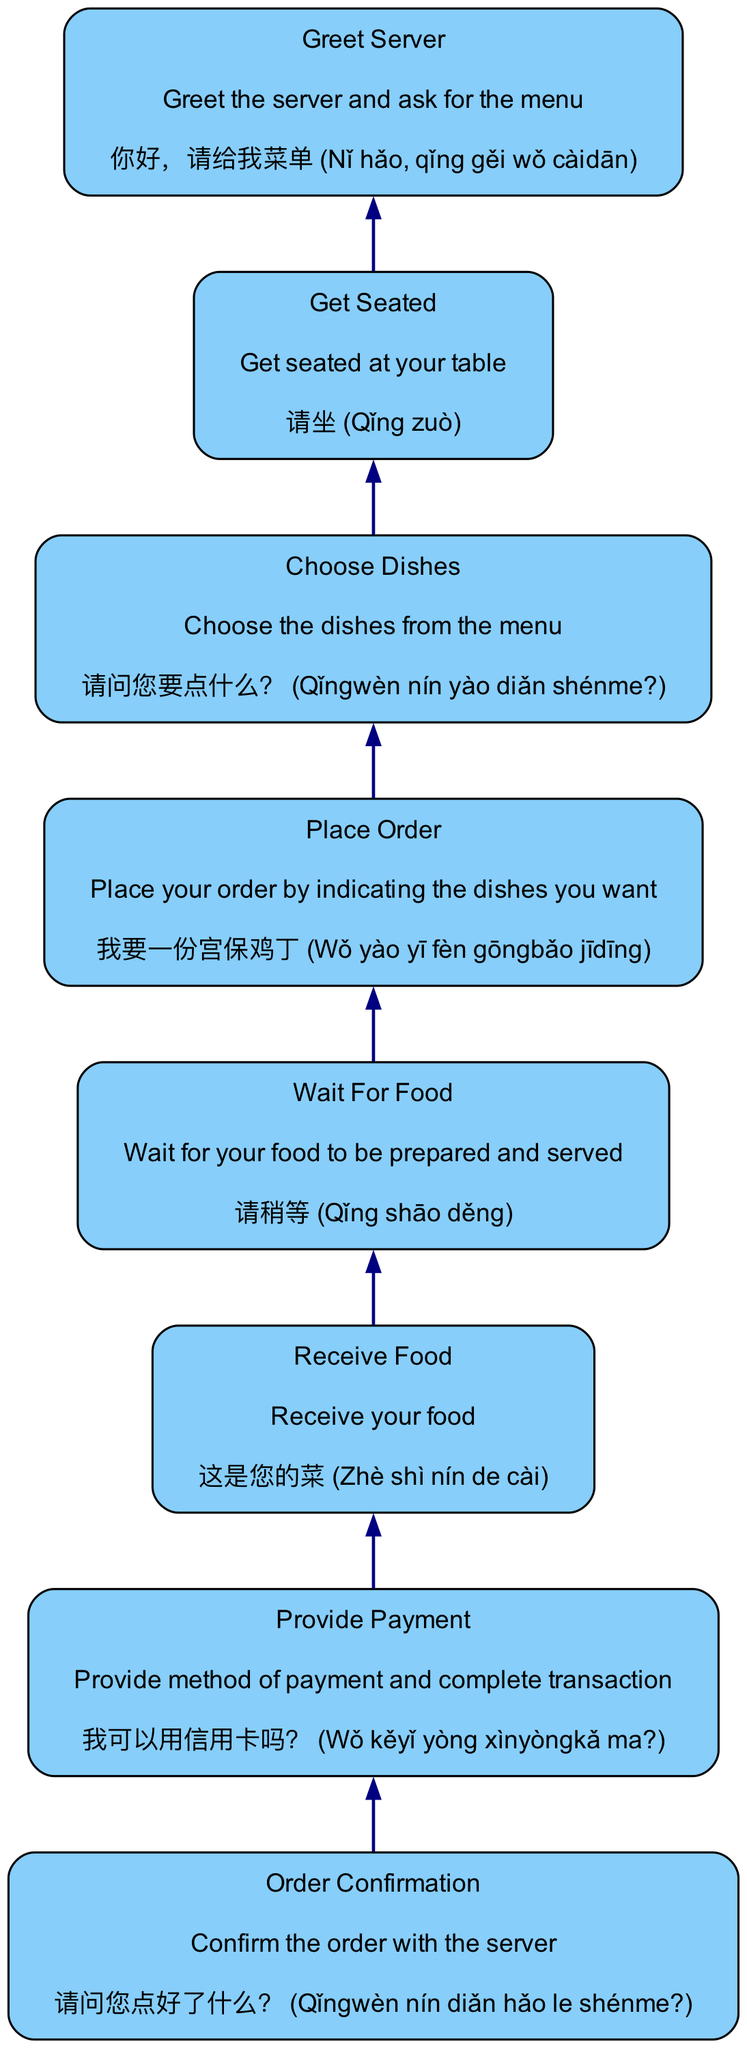What is the last step in the diagram? The last step listed in the diagram is "order confirmation," as it appears at the top of the flowchart indicating the final action to take after receiving food.
Answer: order confirmation How many steps are in the diagram? By counting the individual steps provided in the diagram, there are a total of eight different steps listed sequentially from bottom to top.
Answer: 8 Which step comes after 'get seated'? The step that comes immediately after 'get seated' is 'greet server,' as the flow moves from one action to the next based on the sequence provided in the diagram.
Answer: greet server What is the example Mandarin phrase for 'receive food'? The example phrase for 'receive food' is given as "这是您的菜," which translates to explaining that the food being served belongs to the customer.
Answer: 这是您的菜 (Zhè shì nín de cài) What is the relationship between 'place order' and 'wait for food'? The flow indicates that after placing an order, the next action is to wait for food, illustrating a direct sequence where one action logically leads to the next within the context of ordering food.
Answer: Place order → Wait for food What action is required before providing payment? Before providing payment, one must wait for food to be prepared and served, confirming that this step is a prerequisite for completing the transaction.
Answer: wait for food Which step includes asking for the menu? The step that involves asking for the menu is 'greet server,' as it is stated that greeting the server includes requesting the menu to choose from.
Answer: greet server How is payment completed in the diagram? Payment is completed by indicating the method of payment in the 'provide payment' step, which directly follows receiving the food and confirms the transaction is finalized.
Answer: provide payment 